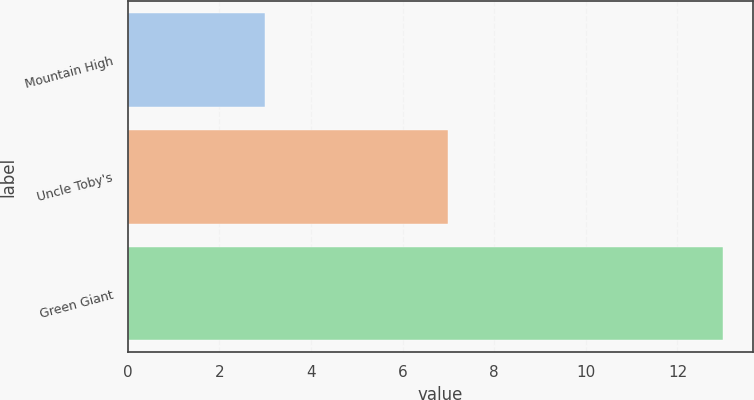Convert chart to OTSL. <chart><loc_0><loc_0><loc_500><loc_500><bar_chart><fcel>Mountain High<fcel>Uncle Toby's<fcel>Green Giant<nl><fcel>3<fcel>7<fcel>13<nl></chart> 